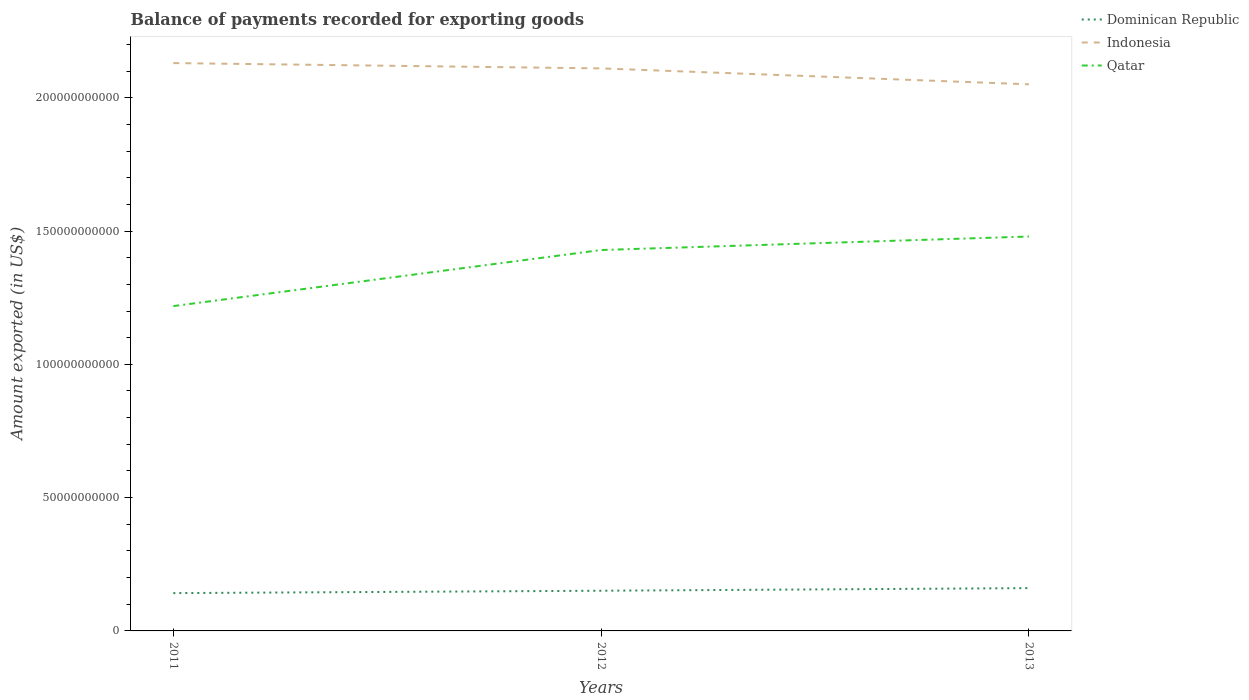Is the number of lines equal to the number of legend labels?
Provide a short and direct response. Yes. Across all years, what is the maximum amount exported in Dominican Republic?
Make the answer very short. 1.42e+1. What is the total amount exported in Qatar in the graph?
Give a very brief answer. -5.07e+09. What is the difference between the highest and the second highest amount exported in Dominican Republic?
Provide a succinct answer. 1.87e+09. How many years are there in the graph?
Provide a short and direct response. 3. What is the difference between two consecutive major ticks on the Y-axis?
Offer a terse response. 5.00e+1. Does the graph contain grids?
Your response must be concise. No. Where does the legend appear in the graph?
Make the answer very short. Top right. How many legend labels are there?
Keep it short and to the point. 3. What is the title of the graph?
Your response must be concise. Balance of payments recorded for exporting goods. What is the label or title of the Y-axis?
Offer a very short reply. Amount exported (in US$). What is the Amount exported (in US$) of Dominican Republic in 2011?
Your response must be concise. 1.42e+1. What is the Amount exported (in US$) of Indonesia in 2011?
Provide a short and direct response. 2.13e+11. What is the Amount exported (in US$) of Qatar in 2011?
Provide a succinct answer. 1.22e+11. What is the Amount exported (in US$) in Dominican Republic in 2012?
Your answer should be compact. 1.51e+1. What is the Amount exported (in US$) in Indonesia in 2012?
Ensure brevity in your answer.  2.11e+11. What is the Amount exported (in US$) in Qatar in 2012?
Offer a very short reply. 1.43e+11. What is the Amount exported (in US$) of Dominican Republic in 2013?
Make the answer very short. 1.61e+1. What is the Amount exported (in US$) of Indonesia in 2013?
Ensure brevity in your answer.  2.05e+11. What is the Amount exported (in US$) of Qatar in 2013?
Make the answer very short. 1.48e+11. Across all years, what is the maximum Amount exported (in US$) of Dominican Republic?
Make the answer very short. 1.61e+1. Across all years, what is the maximum Amount exported (in US$) of Indonesia?
Offer a terse response. 2.13e+11. Across all years, what is the maximum Amount exported (in US$) of Qatar?
Your response must be concise. 1.48e+11. Across all years, what is the minimum Amount exported (in US$) in Dominican Republic?
Give a very brief answer. 1.42e+1. Across all years, what is the minimum Amount exported (in US$) of Indonesia?
Give a very brief answer. 2.05e+11. Across all years, what is the minimum Amount exported (in US$) in Qatar?
Keep it short and to the point. 1.22e+11. What is the total Amount exported (in US$) in Dominican Republic in the graph?
Offer a very short reply. 4.53e+1. What is the total Amount exported (in US$) of Indonesia in the graph?
Your answer should be compact. 6.29e+11. What is the total Amount exported (in US$) in Qatar in the graph?
Your answer should be compact. 4.13e+11. What is the difference between the Amount exported (in US$) in Dominican Republic in 2011 and that in 2012?
Provide a short and direct response. -8.91e+08. What is the difference between the Amount exported (in US$) in Indonesia in 2011 and that in 2012?
Provide a succinct answer. 1.99e+09. What is the difference between the Amount exported (in US$) in Qatar in 2011 and that in 2012?
Ensure brevity in your answer.  -2.10e+1. What is the difference between the Amount exported (in US$) of Dominican Republic in 2011 and that in 2013?
Your answer should be compact. -1.87e+09. What is the difference between the Amount exported (in US$) in Indonesia in 2011 and that in 2013?
Your response must be concise. 7.96e+09. What is the difference between the Amount exported (in US$) of Qatar in 2011 and that in 2013?
Your answer should be compact. -2.61e+1. What is the difference between the Amount exported (in US$) of Dominican Republic in 2012 and that in 2013?
Offer a very short reply. -9.77e+08. What is the difference between the Amount exported (in US$) in Indonesia in 2012 and that in 2013?
Offer a terse response. 5.97e+09. What is the difference between the Amount exported (in US$) of Qatar in 2012 and that in 2013?
Make the answer very short. -5.07e+09. What is the difference between the Amount exported (in US$) in Dominican Republic in 2011 and the Amount exported (in US$) in Indonesia in 2012?
Give a very brief answer. -1.97e+11. What is the difference between the Amount exported (in US$) in Dominican Republic in 2011 and the Amount exported (in US$) in Qatar in 2012?
Provide a short and direct response. -1.29e+11. What is the difference between the Amount exported (in US$) in Indonesia in 2011 and the Amount exported (in US$) in Qatar in 2012?
Ensure brevity in your answer.  7.01e+1. What is the difference between the Amount exported (in US$) of Dominican Republic in 2011 and the Amount exported (in US$) of Indonesia in 2013?
Your response must be concise. -1.91e+11. What is the difference between the Amount exported (in US$) in Dominican Republic in 2011 and the Amount exported (in US$) in Qatar in 2013?
Offer a terse response. -1.34e+11. What is the difference between the Amount exported (in US$) in Indonesia in 2011 and the Amount exported (in US$) in Qatar in 2013?
Ensure brevity in your answer.  6.51e+1. What is the difference between the Amount exported (in US$) in Dominican Republic in 2012 and the Amount exported (in US$) in Indonesia in 2013?
Offer a very short reply. -1.90e+11. What is the difference between the Amount exported (in US$) in Dominican Republic in 2012 and the Amount exported (in US$) in Qatar in 2013?
Provide a succinct answer. -1.33e+11. What is the difference between the Amount exported (in US$) in Indonesia in 2012 and the Amount exported (in US$) in Qatar in 2013?
Give a very brief answer. 6.31e+1. What is the average Amount exported (in US$) in Dominican Republic per year?
Offer a terse response. 1.51e+1. What is the average Amount exported (in US$) of Indonesia per year?
Keep it short and to the point. 2.10e+11. What is the average Amount exported (in US$) in Qatar per year?
Make the answer very short. 1.38e+11. In the year 2011, what is the difference between the Amount exported (in US$) of Dominican Republic and Amount exported (in US$) of Indonesia?
Your response must be concise. -1.99e+11. In the year 2011, what is the difference between the Amount exported (in US$) of Dominican Republic and Amount exported (in US$) of Qatar?
Give a very brief answer. -1.08e+11. In the year 2011, what is the difference between the Amount exported (in US$) of Indonesia and Amount exported (in US$) of Qatar?
Give a very brief answer. 9.12e+1. In the year 2012, what is the difference between the Amount exported (in US$) of Dominican Republic and Amount exported (in US$) of Indonesia?
Offer a very short reply. -1.96e+11. In the year 2012, what is the difference between the Amount exported (in US$) of Dominican Republic and Amount exported (in US$) of Qatar?
Ensure brevity in your answer.  -1.28e+11. In the year 2012, what is the difference between the Amount exported (in US$) of Indonesia and Amount exported (in US$) of Qatar?
Give a very brief answer. 6.81e+1. In the year 2013, what is the difference between the Amount exported (in US$) in Dominican Republic and Amount exported (in US$) in Indonesia?
Ensure brevity in your answer.  -1.89e+11. In the year 2013, what is the difference between the Amount exported (in US$) in Dominican Republic and Amount exported (in US$) in Qatar?
Your answer should be compact. -1.32e+11. In the year 2013, what is the difference between the Amount exported (in US$) of Indonesia and Amount exported (in US$) of Qatar?
Offer a very short reply. 5.71e+1. What is the ratio of the Amount exported (in US$) in Dominican Republic in 2011 to that in 2012?
Give a very brief answer. 0.94. What is the ratio of the Amount exported (in US$) of Indonesia in 2011 to that in 2012?
Your response must be concise. 1.01. What is the ratio of the Amount exported (in US$) of Qatar in 2011 to that in 2012?
Provide a succinct answer. 0.85. What is the ratio of the Amount exported (in US$) in Dominican Republic in 2011 to that in 2013?
Keep it short and to the point. 0.88. What is the ratio of the Amount exported (in US$) of Indonesia in 2011 to that in 2013?
Your response must be concise. 1.04. What is the ratio of the Amount exported (in US$) in Qatar in 2011 to that in 2013?
Your response must be concise. 0.82. What is the ratio of the Amount exported (in US$) of Dominican Republic in 2012 to that in 2013?
Your answer should be very brief. 0.94. What is the ratio of the Amount exported (in US$) in Indonesia in 2012 to that in 2013?
Your response must be concise. 1.03. What is the ratio of the Amount exported (in US$) in Qatar in 2012 to that in 2013?
Provide a short and direct response. 0.97. What is the difference between the highest and the second highest Amount exported (in US$) in Dominican Republic?
Give a very brief answer. 9.77e+08. What is the difference between the highest and the second highest Amount exported (in US$) of Indonesia?
Provide a short and direct response. 1.99e+09. What is the difference between the highest and the second highest Amount exported (in US$) of Qatar?
Offer a very short reply. 5.07e+09. What is the difference between the highest and the lowest Amount exported (in US$) in Dominican Republic?
Ensure brevity in your answer.  1.87e+09. What is the difference between the highest and the lowest Amount exported (in US$) in Indonesia?
Your answer should be compact. 7.96e+09. What is the difference between the highest and the lowest Amount exported (in US$) of Qatar?
Provide a short and direct response. 2.61e+1. 